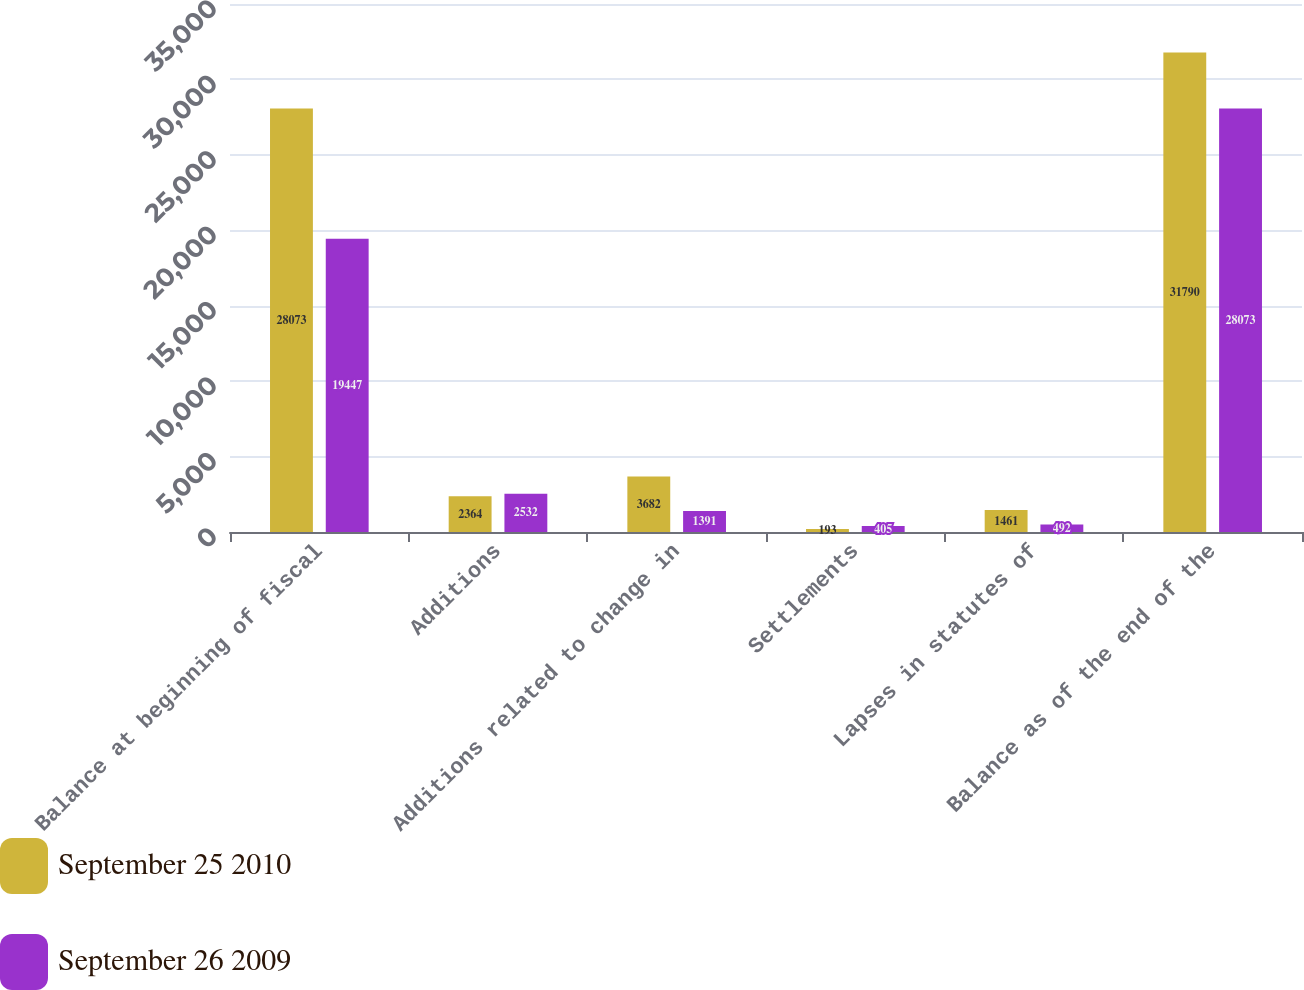<chart> <loc_0><loc_0><loc_500><loc_500><stacked_bar_chart><ecel><fcel>Balance at beginning of fiscal<fcel>Additions<fcel>Additions related to change in<fcel>Settlements<fcel>Lapses in statutes of<fcel>Balance as of the end of the<nl><fcel>September 25 2010<fcel>28073<fcel>2364<fcel>3682<fcel>193<fcel>1461<fcel>31790<nl><fcel>September 26 2009<fcel>19447<fcel>2532<fcel>1391<fcel>405<fcel>492<fcel>28073<nl></chart> 